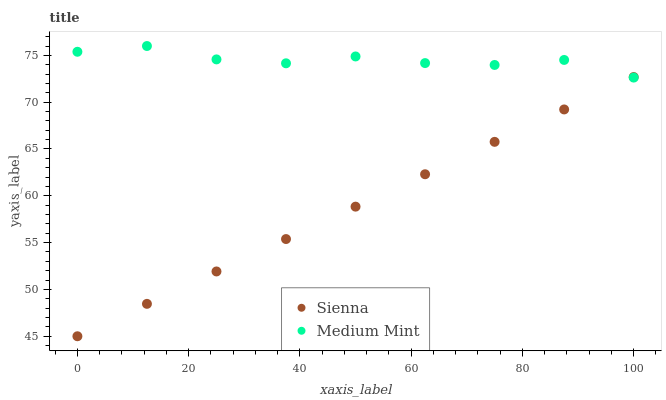Does Sienna have the minimum area under the curve?
Answer yes or no. Yes. Does Medium Mint have the maximum area under the curve?
Answer yes or no. Yes. Does Medium Mint have the minimum area under the curve?
Answer yes or no. No. Is Sienna the smoothest?
Answer yes or no. Yes. Is Medium Mint the roughest?
Answer yes or no. Yes. Is Medium Mint the smoothest?
Answer yes or no. No. Does Sienna have the lowest value?
Answer yes or no. Yes. Does Medium Mint have the lowest value?
Answer yes or no. No. Does Medium Mint have the highest value?
Answer yes or no. Yes. Does Sienna intersect Medium Mint?
Answer yes or no. Yes. Is Sienna less than Medium Mint?
Answer yes or no. No. Is Sienna greater than Medium Mint?
Answer yes or no. No. 